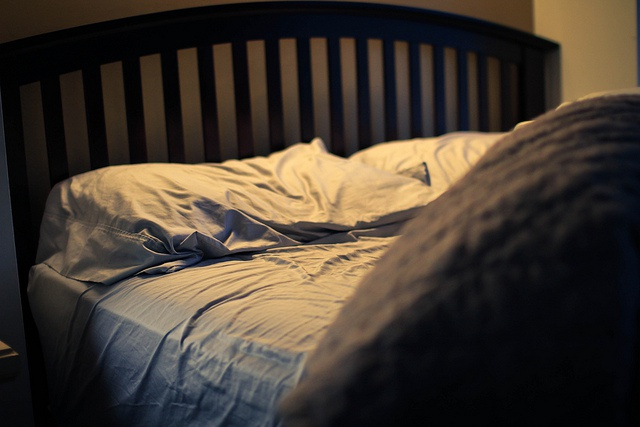Describe the objects in this image and their specific colors. I can see a bed in black, tan, and gray tones in this image. 